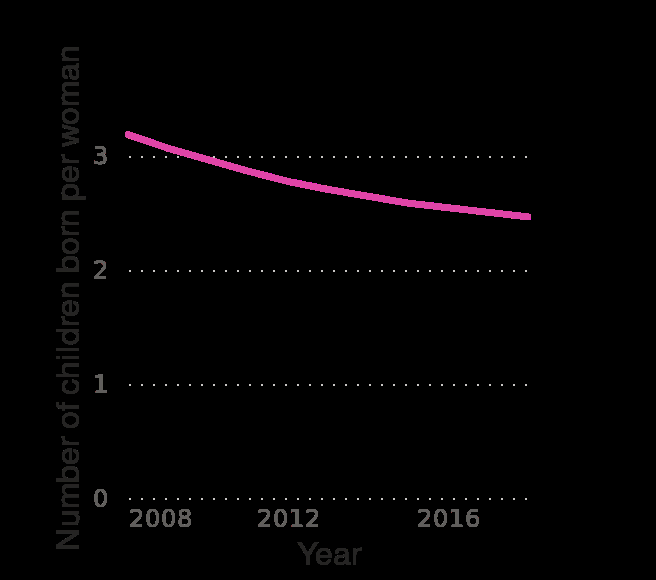<image>
What is the maximum year displayed on the x-axis? The maximum year displayed on the x-axis is 2016. How is fertility rate changing in Honduras? The fertility rate in Honduras is decreasing over time. 